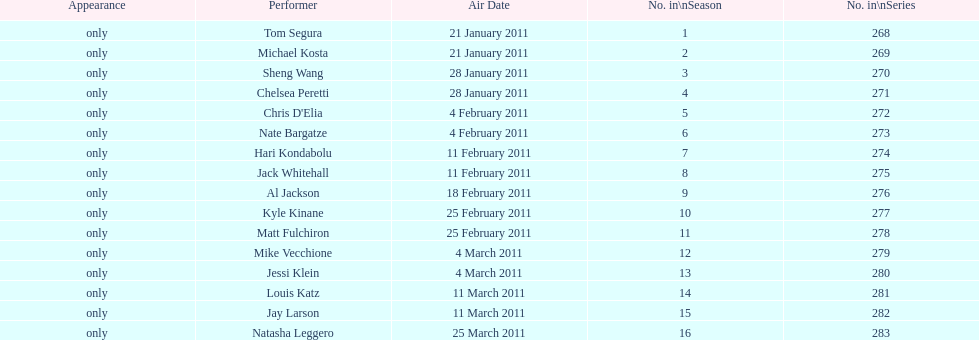What was hari's last name? Kondabolu. 